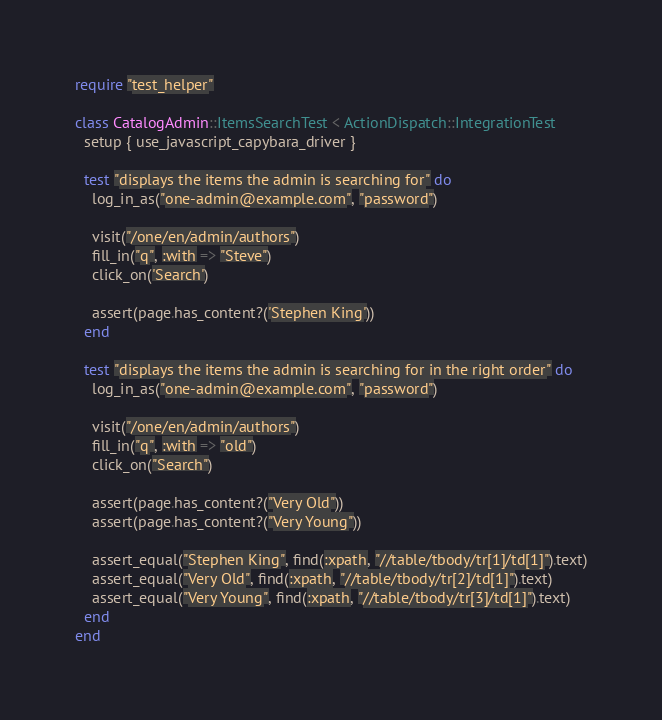Convert code to text. <code><loc_0><loc_0><loc_500><loc_500><_Ruby_>require "test_helper"

class CatalogAdmin::ItemsSearchTest < ActionDispatch::IntegrationTest
  setup { use_javascript_capybara_driver }

  test "displays the items the admin is searching for" do
    log_in_as("one-admin@example.com", "password")

    visit("/one/en/admin/authors")
    fill_in("q", :with => "Steve")
    click_on('Search')

    assert(page.has_content?('Stephen King'))
  end

  test "displays the items the admin is searching for in the right order" do
    log_in_as("one-admin@example.com", "password")

    visit("/one/en/admin/authors")
    fill_in("q", :with => "old")
    click_on("Search")

    assert(page.has_content?("Very Old"))
    assert(page.has_content?("Very Young"))

    assert_equal("Stephen King", find(:xpath, "//table/tbody/tr[1]/td[1]").text)
    assert_equal("Very Old", find(:xpath, "//table/tbody/tr[2]/td[1]").text)
    assert_equal("Very Young", find(:xpath, "//table/tbody/tr[3]/td[1]").text)
  end
end
</code> 